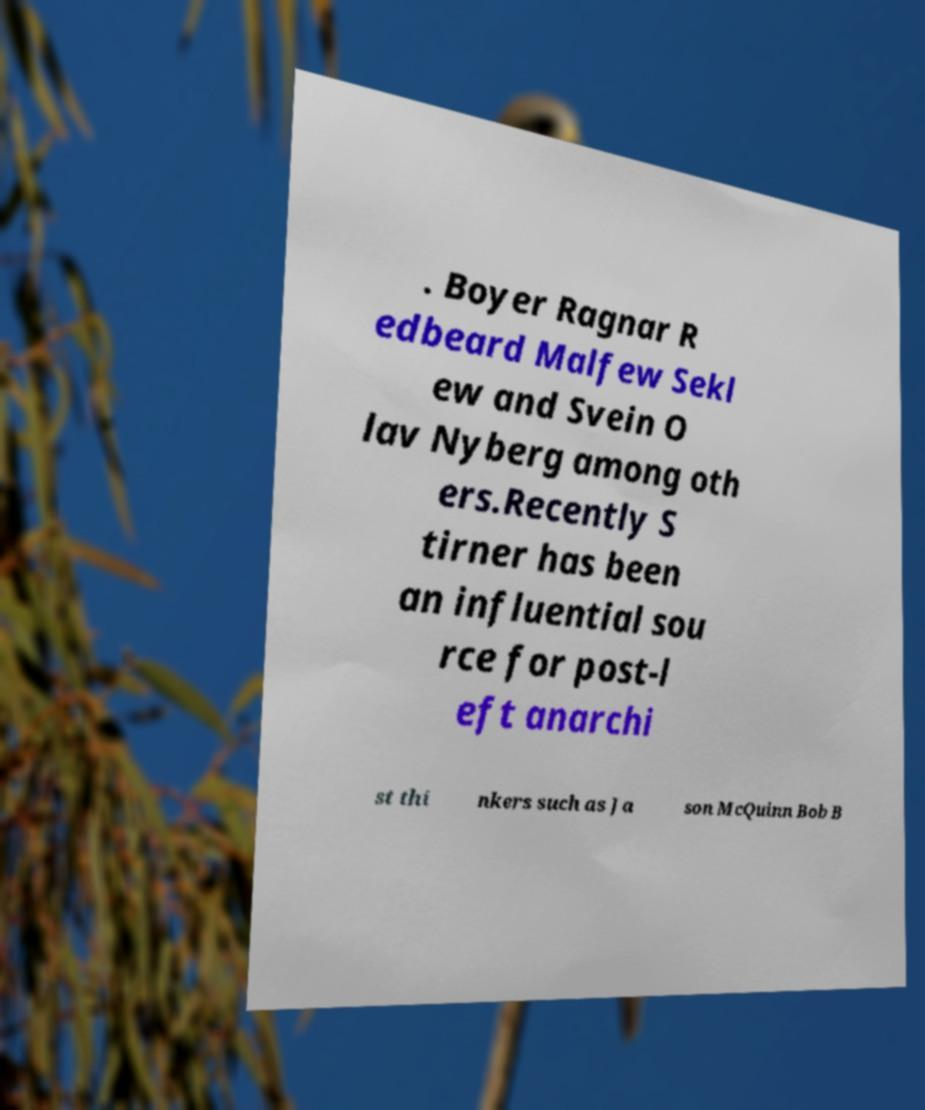Could you extract and type out the text from this image? . Boyer Ragnar R edbeard Malfew Sekl ew and Svein O lav Nyberg among oth ers.Recently S tirner has been an influential sou rce for post-l eft anarchi st thi nkers such as Ja son McQuinn Bob B 